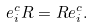Convert formula to latex. <formula><loc_0><loc_0><loc_500><loc_500>e ^ { c } _ { i } R = R e ^ { c } _ { i } .</formula> 